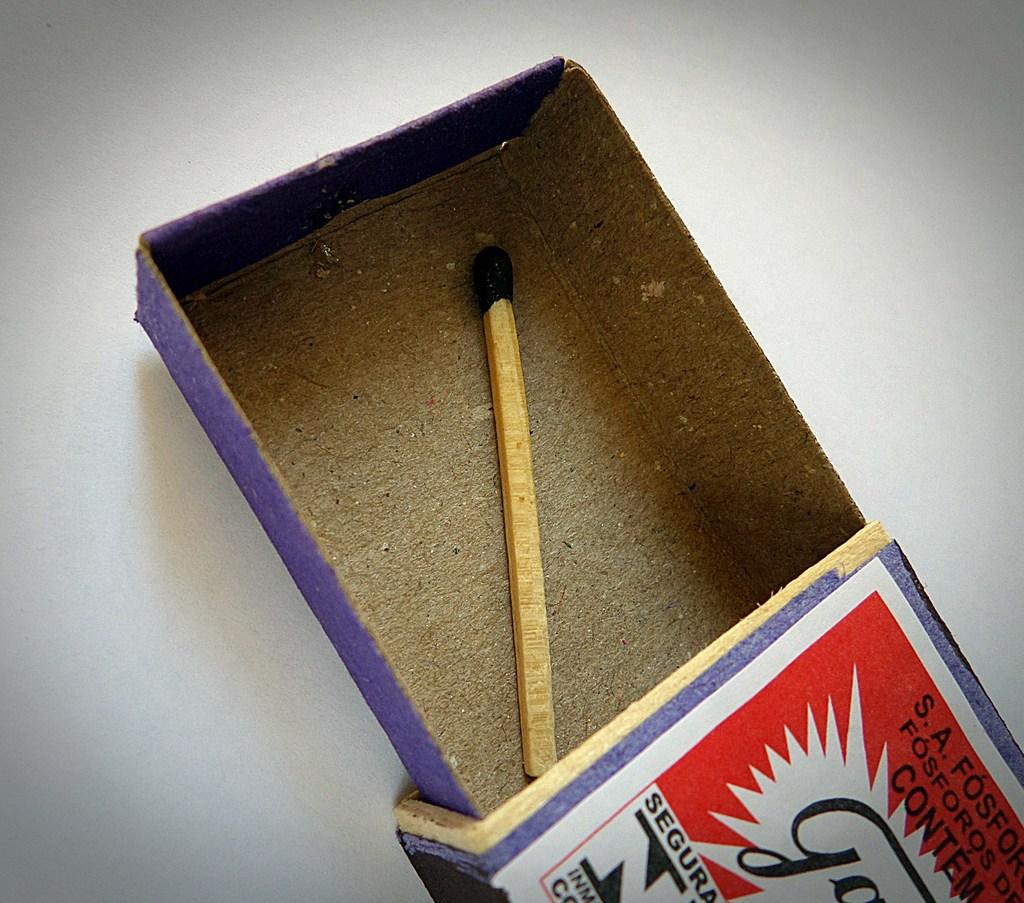What company makes this?
Provide a short and direct response. Segura. What is the large letter in white on the blue background?
Ensure brevity in your answer.  N. 